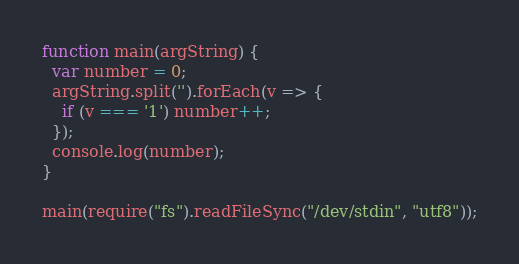Convert code to text. <code><loc_0><loc_0><loc_500><loc_500><_JavaScript_>function main(argString) {
  var number = 0;
  argString.split('').forEach(v => {
    if (v === '1') number++;
  });
  console.log(number);
}

main(require("fs").readFileSync("/dev/stdin", "utf8"));</code> 